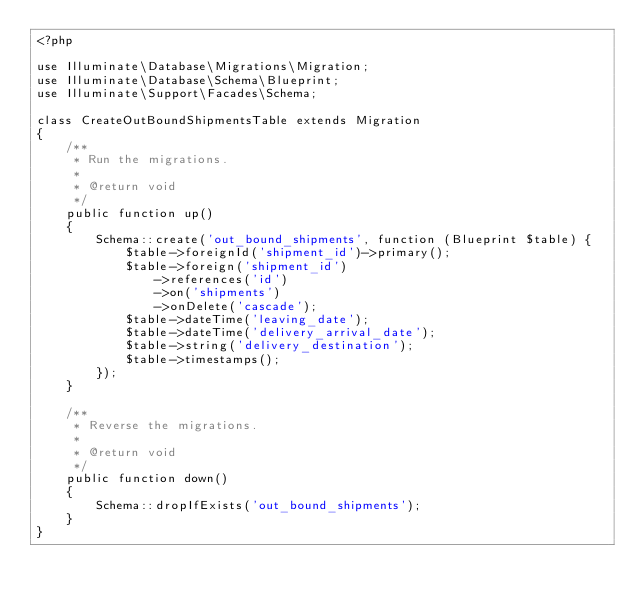Convert code to text. <code><loc_0><loc_0><loc_500><loc_500><_PHP_><?php

use Illuminate\Database\Migrations\Migration;
use Illuminate\Database\Schema\Blueprint;
use Illuminate\Support\Facades\Schema;

class CreateOutBoundShipmentsTable extends Migration
{
    /**
     * Run the migrations.
     *
     * @return void
     */
    public function up()
    {
        Schema::create('out_bound_shipments', function (Blueprint $table) {
            $table->foreignId('shipment_id')->primary();
            $table->foreign('shipment_id')
                ->references('id')
                ->on('shipments')
                ->onDelete('cascade');
            $table->dateTime('leaving_date');
            $table->dateTime('delivery_arrival_date');
            $table->string('delivery_destination');
            $table->timestamps();
        });
    }

    /**
     * Reverse the migrations.
     *
     * @return void
     */
    public function down()
    {
        Schema::dropIfExists('out_bound_shipments');
    }
}
</code> 